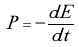<formula> <loc_0><loc_0><loc_500><loc_500>P = - \frac { d E } { d t }</formula> 